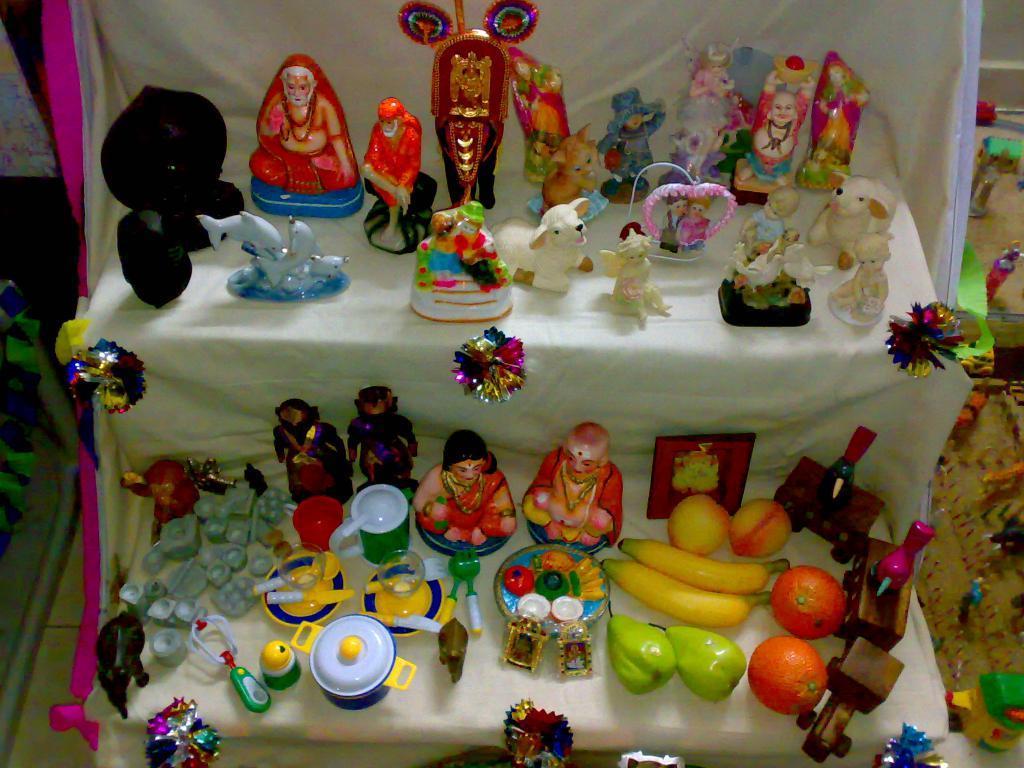Describe this image in one or two sentences. In this picture we can see statues, dolls, toys and objects on the stand. On the right side of the image we can see toys. On the left side of the image we can see objects. 